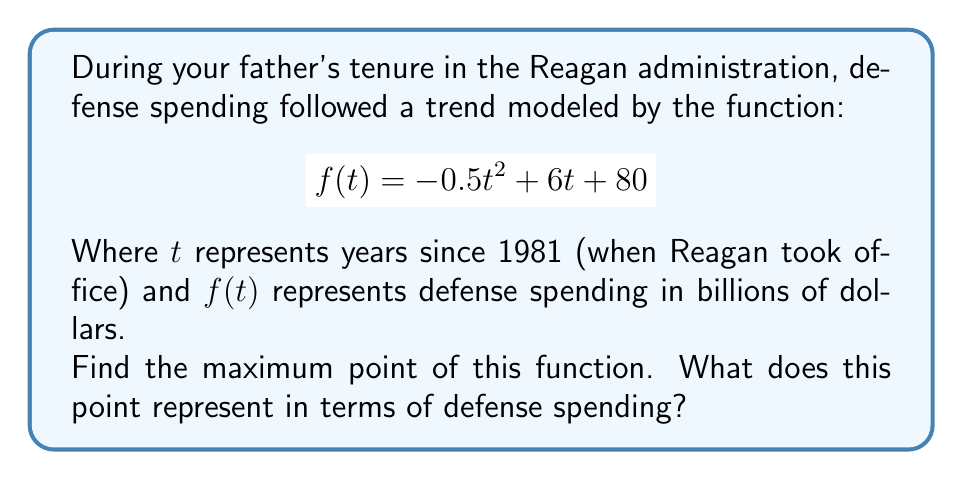Help me with this question. To find the maximum point of the function, we need to follow these steps:

1) First, we need to find the derivative of the function:
   $$f'(t) = -t + 6$$

2) Set the derivative equal to zero to find the critical point:
   $$-t + 6 = 0$$
   $$t = 6$$

3) To confirm this is a maximum, we can check the second derivative:
   $$f''(t) = -1$$
   Since $f''(t)$ is negative, this confirms that $t = 6$ is indeed a maximum point.

4) Now, we need to find the y-coordinate of this maximum point by plugging $t = 6$ into our original function:
   $$f(6) = -0.5(6)^2 + 6(6) + 80$$
   $$    = -18 + 36 + 80$$
   $$    = 98$$

5) Therefore, the maximum point is (6, 98).

Interpretation: This means that defense spending reached its peak 6 years after Reagan took office (in 1987) at $98 billion.
Answer: (6, 98) 